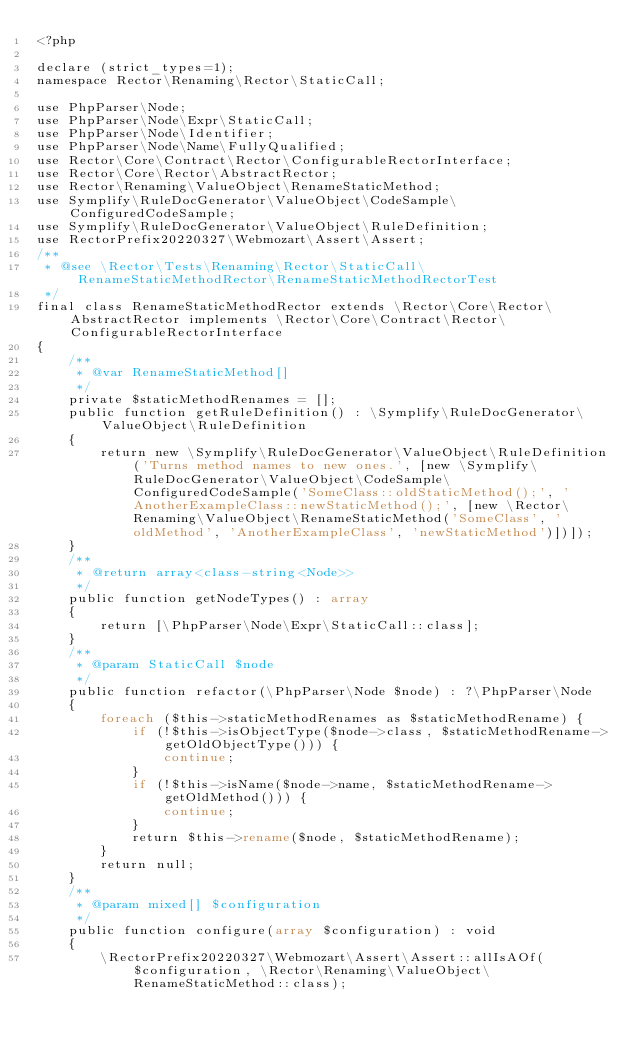Convert code to text. <code><loc_0><loc_0><loc_500><loc_500><_PHP_><?php

declare (strict_types=1);
namespace Rector\Renaming\Rector\StaticCall;

use PhpParser\Node;
use PhpParser\Node\Expr\StaticCall;
use PhpParser\Node\Identifier;
use PhpParser\Node\Name\FullyQualified;
use Rector\Core\Contract\Rector\ConfigurableRectorInterface;
use Rector\Core\Rector\AbstractRector;
use Rector\Renaming\ValueObject\RenameStaticMethod;
use Symplify\RuleDocGenerator\ValueObject\CodeSample\ConfiguredCodeSample;
use Symplify\RuleDocGenerator\ValueObject\RuleDefinition;
use RectorPrefix20220327\Webmozart\Assert\Assert;
/**
 * @see \Rector\Tests\Renaming\Rector\StaticCall\RenameStaticMethodRector\RenameStaticMethodRectorTest
 */
final class RenameStaticMethodRector extends \Rector\Core\Rector\AbstractRector implements \Rector\Core\Contract\Rector\ConfigurableRectorInterface
{
    /**
     * @var RenameStaticMethod[]
     */
    private $staticMethodRenames = [];
    public function getRuleDefinition() : \Symplify\RuleDocGenerator\ValueObject\RuleDefinition
    {
        return new \Symplify\RuleDocGenerator\ValueObject\RuleDefinition('Turns method names to new ones.', [new \Symplify\RuleDocGenerator\ValueObject\CodeSample\ConfiguredCodeSample('SomeClass::oldStaticMethod();', 'AnotherExampleClass::newStaticMethod();', [new \Rector\Renaming\ValueObject\RenameStaticMethod('SomeClass', 'oldMethod', 'AnotherExampleClass', 'newStaticMethod')])]);
    }
    /**
     * @return array<class-string<Node>>
     */
    public function getNodeTypes() : array
    {
        return [\PhpParser\Node\Expr\StaticCall::class];
    }
    /**
     * @param StaticCall $node
     */
    public function refactor(\PhpParser\Node $node) : ?\PhpParser\Node
    {
        foreach ($this->staticMethodRenames as $staticMethodRename) {
            if (!$this->isObjectType($node->class, $staticMethodRename->getOldObjectType())) {
                continue;
            }
            if (!$this->isName($node->name, $staticMethodRename->getOldMethod())) {
                continue;
            }
            return $this->rename($node, $staticMethodRename);
        }
        return null;
    }
    /**
     * @param mixed[] $configuration
     */
    public function configure(array $configuration) : void
    {
        \RectorPrefix20220327\Webmozart\Assert\Assert::allIsAOf($configuration, \Rector\Renaming\ValueObject\RenameStaticMethod::class);</code> 